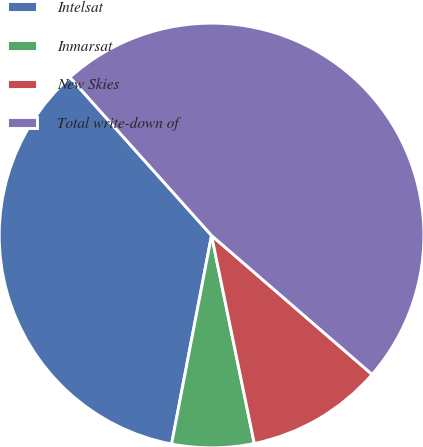Convert chart. <chart><loc_0><loc_0><loc_500><loc_500><pie_chart><fcel>Intelsat<fcel>Inmarsat<fcel>New Skies<fcel>Total write-down of<nl><fcel>35.36%<fcel>6.24%<fcel>10.42%<fcel>47.98%<nl></chart> 